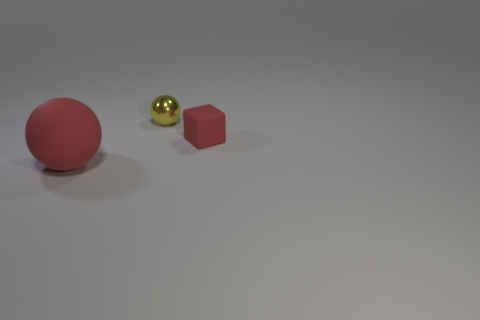How might the size and proportion of these objects influence our perception of them? The varying sizes and proportions create a sense of depth and perspective. The larger red ball appears closer, while the smaller cube and tiny yellow ball seem further away, adding to the three-dimensional effect of the flat image. 